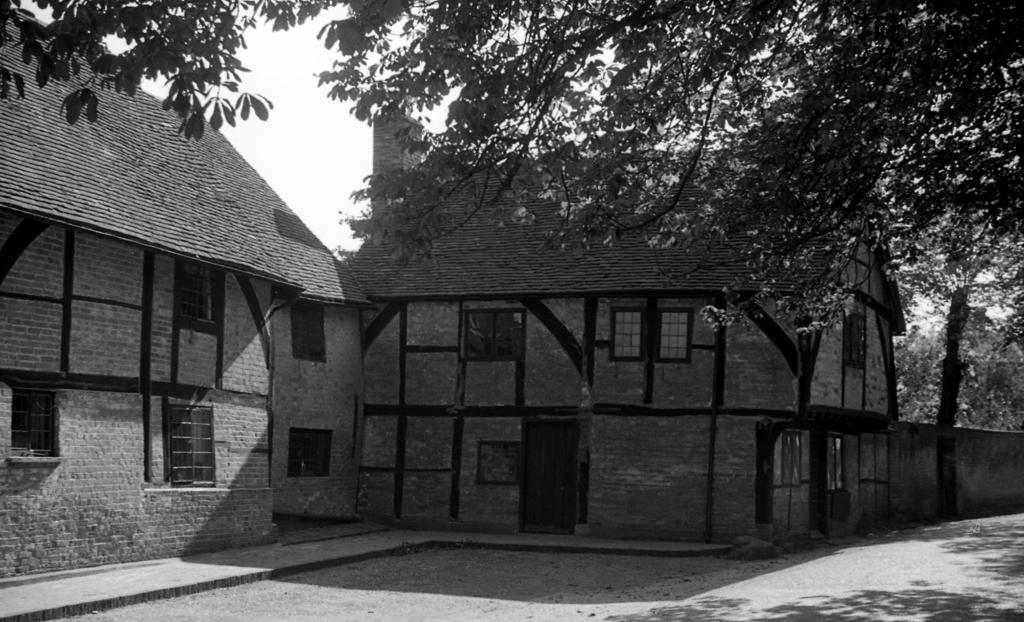What type of buildings are in the image? There are old houses in the image. How are the houses positioned in relation to each other? The houses are side by side. What architectural feature can be seen in the houses? There are windows in the houses. What is the background of the image? There is a wall and trees visible in the image. Can you describe the vegetation in the image? There is a tree in the image, and trees are visible behind the wall. Where is the lunchroom located in the image? There is no lunchroom present in the image. How does the church in the image pull the houses together? There is no church present in the image, and the houses are already side by side. 